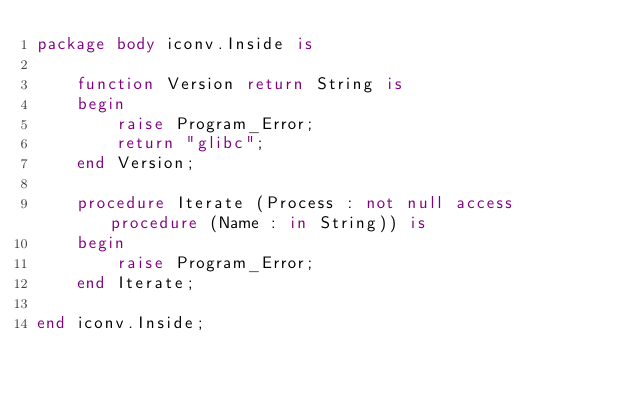Convert code to text. <code><loc_0><loc_0><loc_500><loc_500><_Ada_>package body iconv.Inside is
	
	function Version return String is
	begin
		raise Program_Error;
		return "glibc";
	end Version;
	
	procedure Iterate (Process : not null access procedure (Name : in String)) is
	begin
		raise Program_Error;
	end Iterate;
	
end iconv.Inside;
</code> 